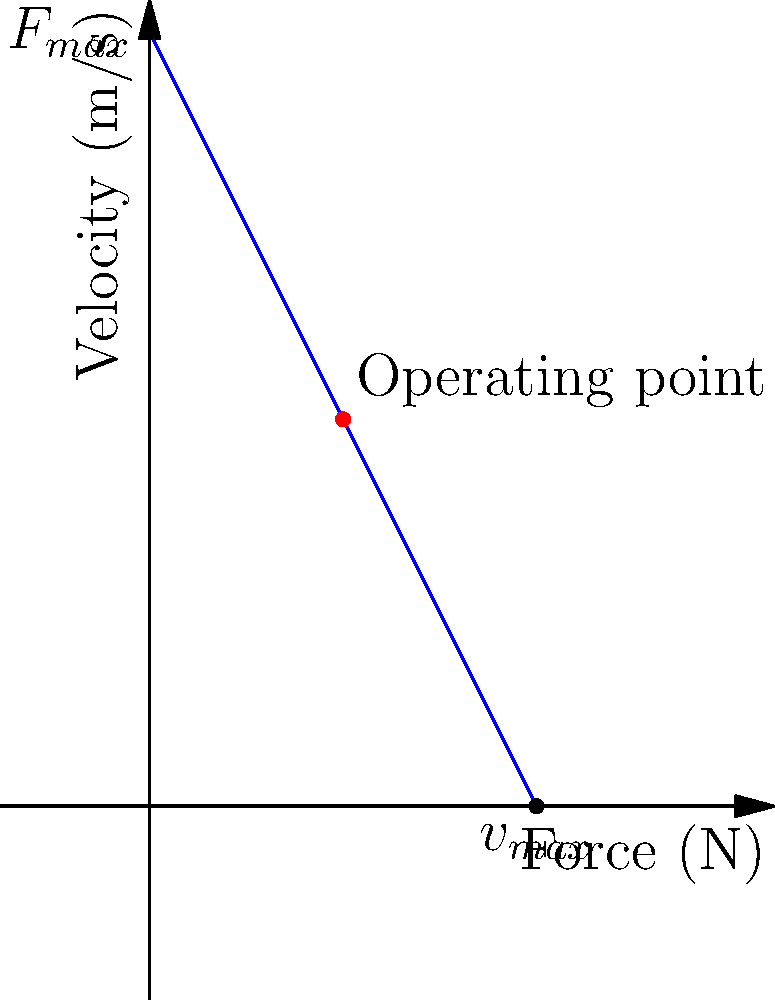In the context of non-lethal crowd control methods, the force-velocity curve for a hypothetical kinetic impact projectile is shown above. If the projectile is designed to operate at the midpoint of this curve, what percentage of its maximum force ($F_{max}$) does it exert at its intended operating point? To solve this problem, we need to follow these steps:

1. Understand the force-velocity curve:
   - The y-intercept represents the maximum force ($F_{max}$) when velocity is zero.
   - The x-intercept represents the maximum velocity ($v_{max}$) when force is zero.

2. Identify the operating point:
   - The operating point is at the midpoint of the curve (red dot).

3. Calculate the force at the operating point:
   - The curve is linear, so we can use the equation of a straight line: $F = F_{max}(1 - \frac{v}{v_{max}})$
   - At the midpoint, $v = \frac{1}{2}v_{max}$
   - Substituting this into the equation: $F = F_{max}(1 - \frac{1/2v_{max}}{v_{max}}) = F_{max}(1 - \frac{1}{2}) = \frac{1}{2}F_{max}$

4. Calculate the percentage:
   - The force at the operating point is $\frac{1}{2}F_{max}$
   - As a percentage, this is $\frac{1}{2} \times 100\% = 50\%$

Therefore, at the intended operating point, the projectile exerts 50% of its maximum force.
Answer: 50% 